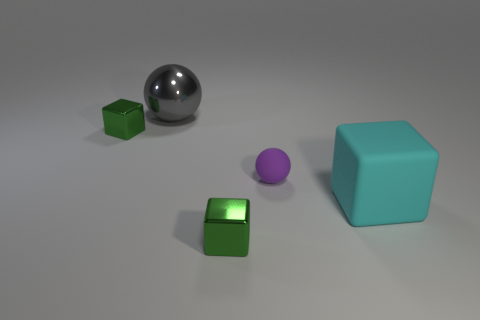Add 2 green objects. How many objects exist? 7 Subtract all blocks. How many objects are left? 2 Subtract 0 blue blocks. How many objects are left? 5 Subtract all matte cubes. Subtract all cyan rubber blocks. How many objects are left? 3 Add 3 large spheres. How many large spheres are left? 4 Add 2 large gray shiny objects. How many large gray shiny objects exist? 3 